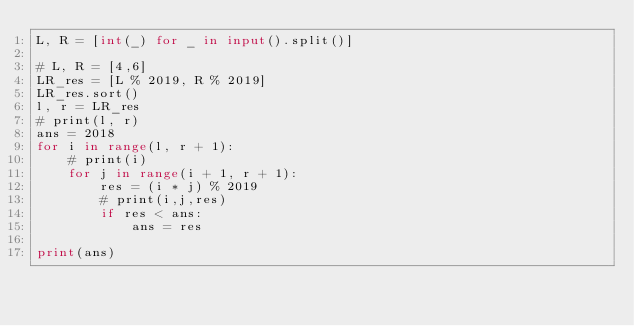<code> <loc_0><loc_0><loc_500><loc_500><_Python_>L, R = [int(_) for _ in input().split()]

# L, R = [4,6]
LR_res = [L % 2019, R % 2019]
LR_res.sort()
l, r = LR_res
# print(l, r)
ans = 2018
for i in range(l, r + 1):
    # print(i)
    for j in range(i + 1, r + 1):
        res = (i * j) % 2019
        # print(i,j,res)
        if res < ans:
            ans = res

print(ans)</code> 